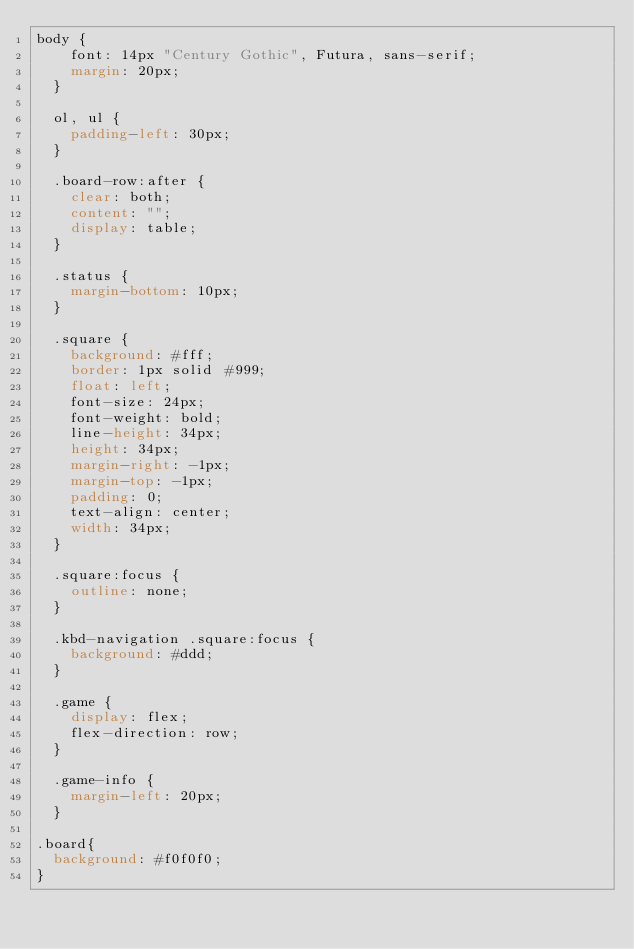Convert code to text. <code><loc_0><loc_0><loc_500><loc_500><_CSS_>body {
    font: 14px "Century Gothic", Futura, sans-serif;
    margin: 20px;
  }
  
  ol, ul {
    padding-left: 30px;
  }
  
  .board-row:after {
    clear: both;
    content: "";
    display: table;
  }
  
  .status {
    margin-bottom: 10px;
  }
  
  .square {
    background: #fff;
    border: 1px solid #999;
    float: left;
    font-size: 24px;
    font-weight: bold;
    line-height: 34px;
    height: 34px;
    margin-right: -1px;
    margin-top: -1px;
    padding: 0;
    text-align: center;
    width: 34px;
  }
  
  .square:focus {
    outline: none;
  }
  
  .kbd-navigation .square:focus {
    background: #ddd;
  }
  
  .game {
    display: flex;
    flex-direction: row;
  }
  
  .game-info {
    margin-left: 20px;
  }

.board{
  background: #f0f0f0;
}</code> 